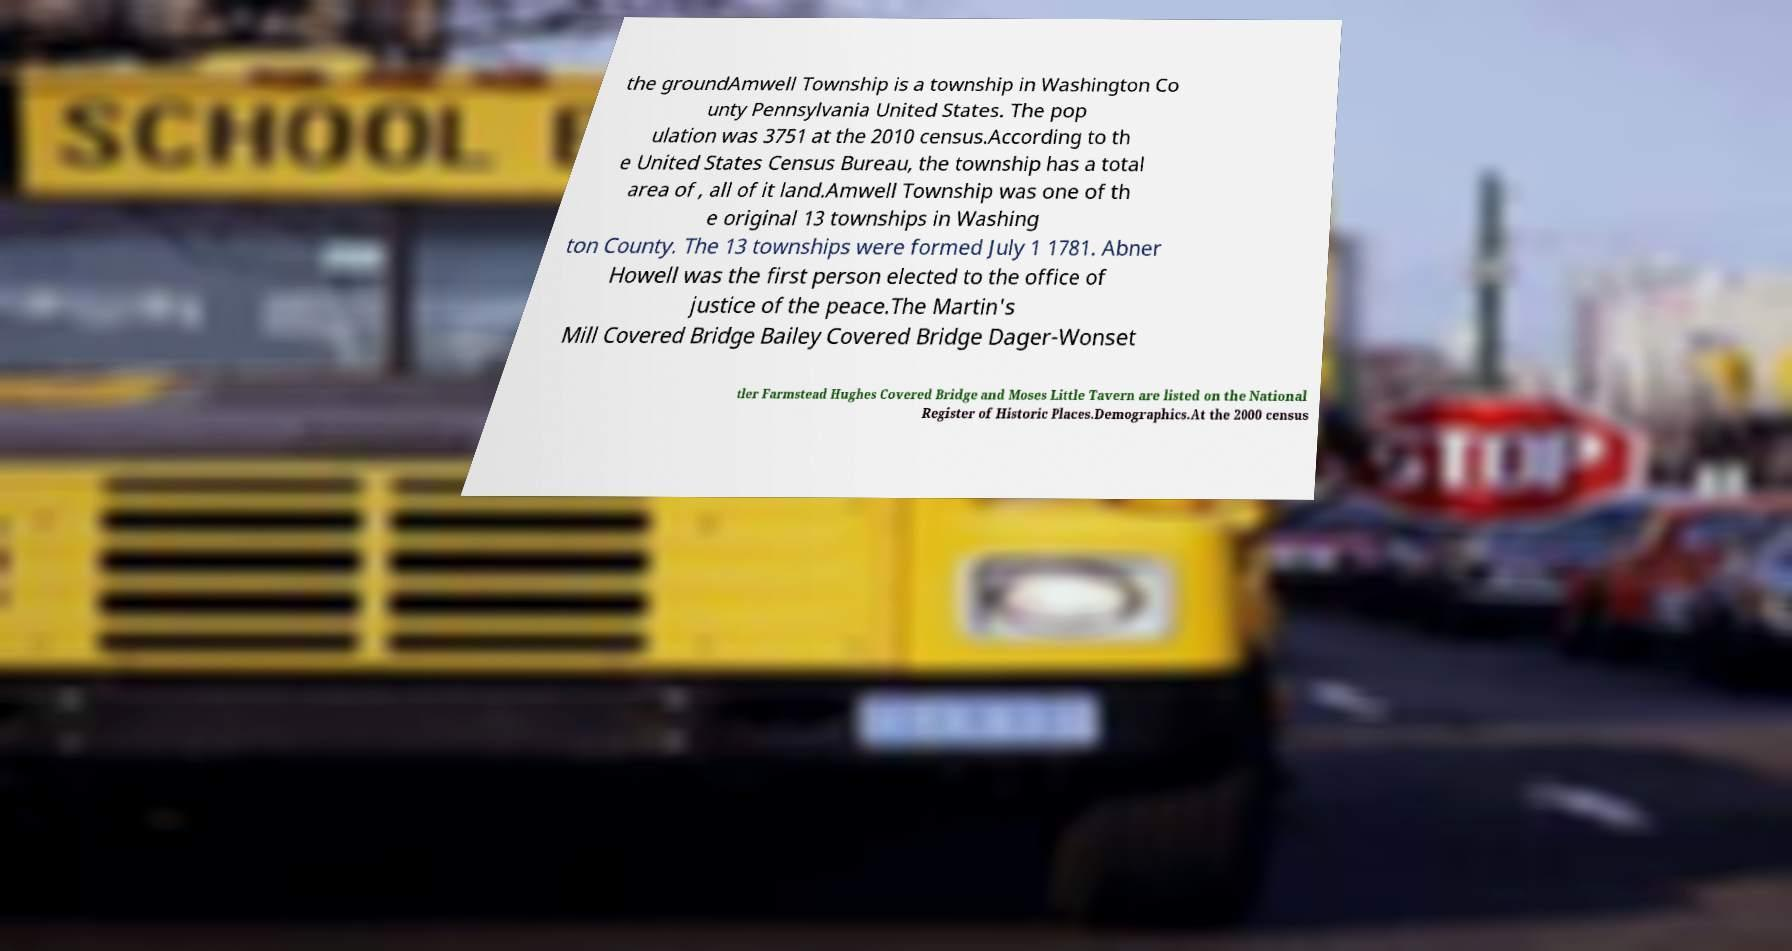Can you accurately transcribe the text from the provided image for me? the groundAmwell Township is a township in Washington Co unty Pennsylvania United States. The pop ulation was 3751 at the 2010 census.According to th e United States Census Bureau, the township has a total area of , all of it land.Amwell Township was one of th e original 13 townships in Washing ton County. The 13 townships were formed July 1 1781. Abner Howell was the first person elected to the office of justice of the peace.The Martin's Mill Covered Bridge Bailey Covered Bridge Dager-Wonset tler Farmstead Hughes Covered Bridge and Moses Little Tavern are listed on the National Register of Historic Places.Demographics.At the 2000 census 